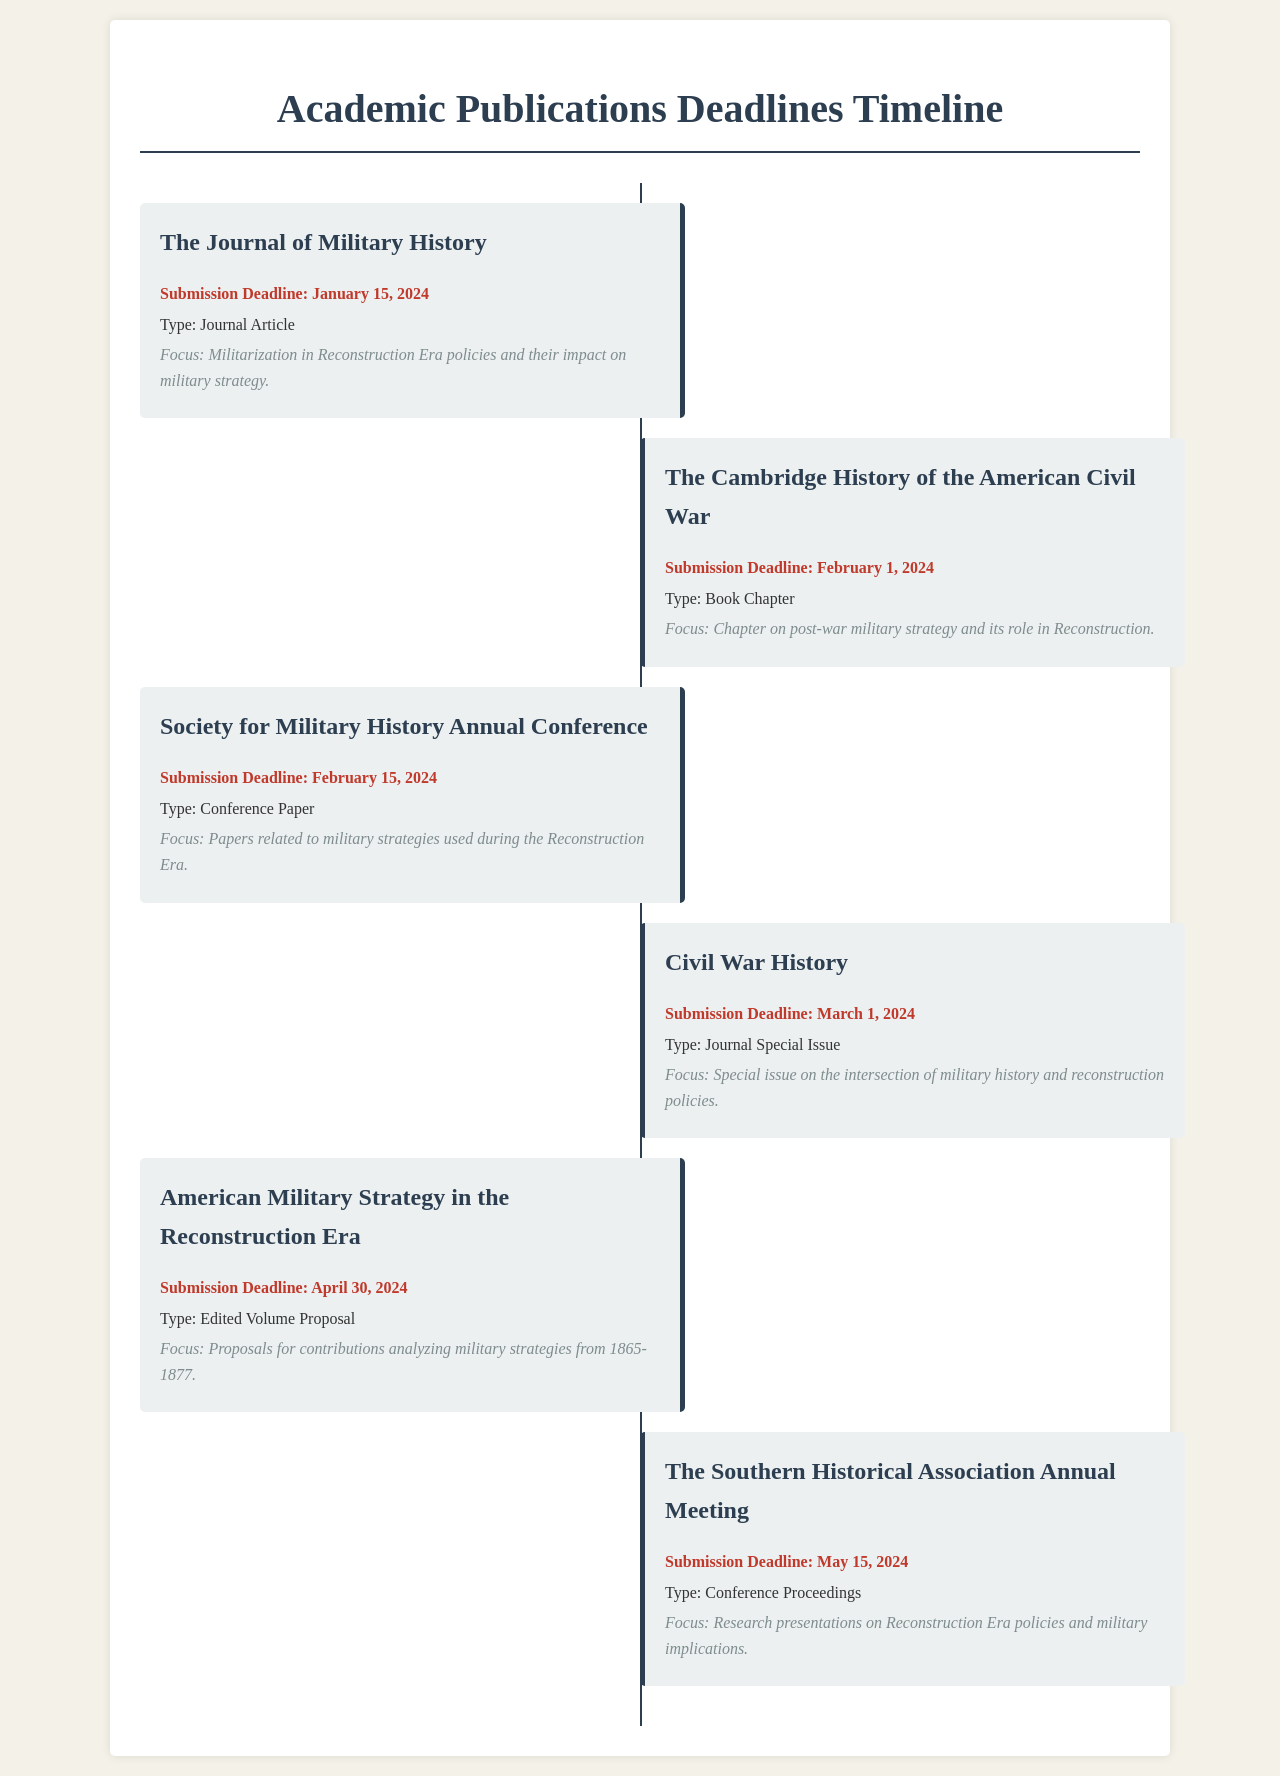what is the submission deadline for The Journal of Military History? The submission deadline for The Journal of Military History is specifically mentioned in the document.
Answer: January 15, 2024 what type of publication is The Cambridge History of the American Civil War? The type of publication is indicated in the document as a book chapter.
Answer: Book Chapter what is the focus of the Society for Military History Annual Conference? The document specifies the focus of this conference paper submission related to military strategies.
Answer: Papers related to military strategies used during the Reconstruction Era how many total submission deadlines are provided in the document? The document lists the number of publications and their deadlines which can be counted to find the total.
Answer: 6 what is the submission deadline for Civil War History? The document explicitly provides the submission deadline for Civil War History.
Answer: March 1, 2024 which journal has a special issue on military history and reconstruction policies? The document identifies the specific journal that has a themed special issue on these topics.
Answer: Civil War History what is the type of submission for American Military Strategy in the Reconstruction Era? The document indicates the specific submission type for this title.
Answer: Edited Volume Proposal when is the submission deadline for the Southern Historical Association Annual Meeting? The document states the exact date for this event's deadline.
Answer: May 15, 2024 